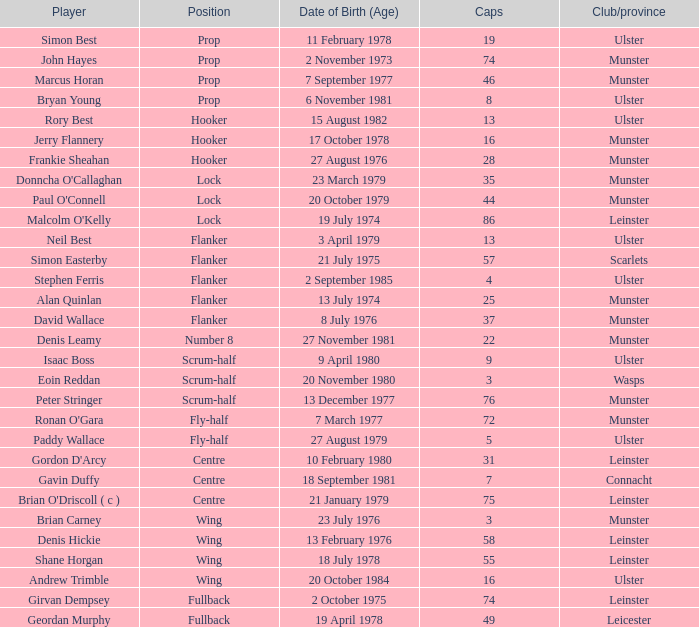Which ulster participant has under 49 caps and takes on the wing role? Andrew Trimble. 